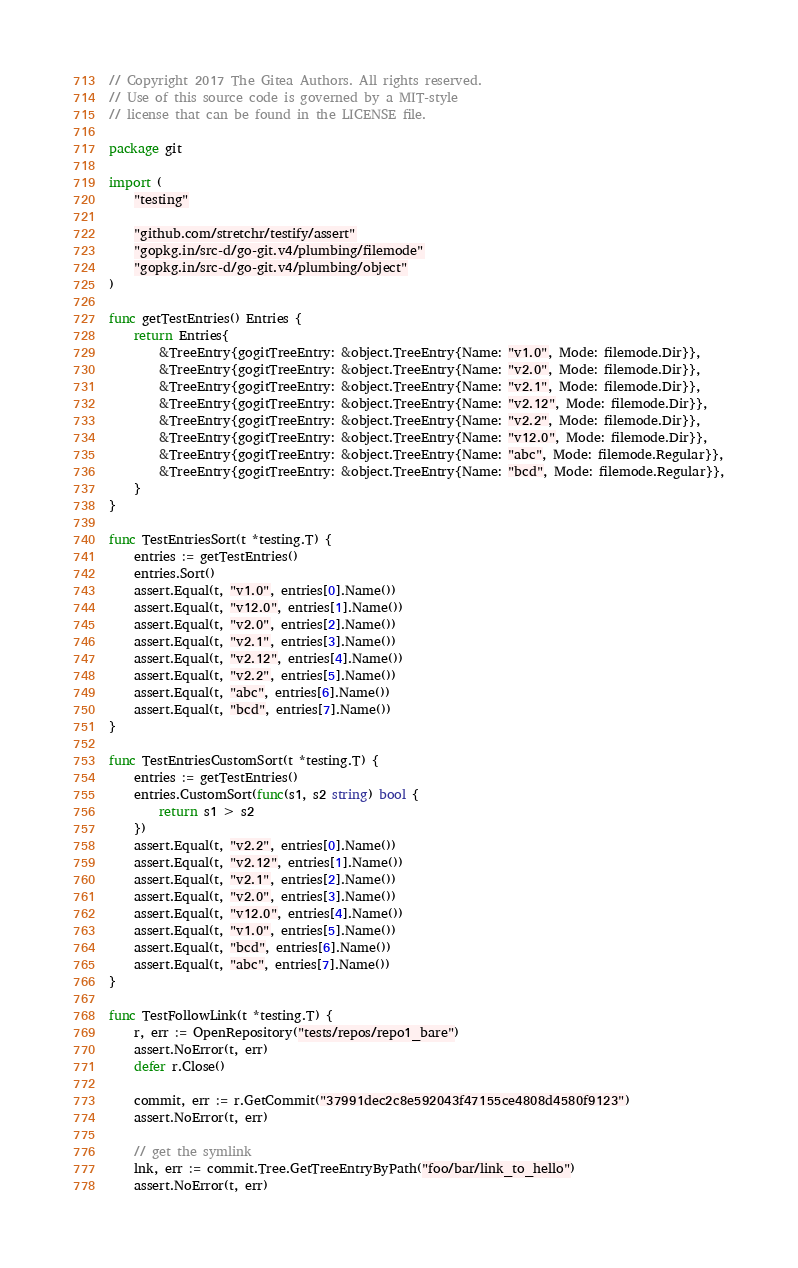<code> <loc_0><loc_0><loc_500><loc_500><_Go_>// Copyright 2017 The Gitea Authors. All rights reserved.
// Use of this source code is governed by a MIT-style
// license that can be found in the LICENSE file.

package git

import (
	"testing"

	"github.com/stretchr/testify/assert"
	"gopkg.in/src-d/go-git.v4/plumbing/filemode"
	"gopkg.in/src-d/go-git.v4/plumbing/object"
)

func getTestEntries() Entries {
	return Entries{
		&TreeEntry{gogitTreeEntry: &object.TreeEntry{Name: "v1.0", Mode: filemode.Dir}},
		&TreeEntry{gogitTreeEntry: &object.TreeEntry{Name: "v2.0", Mode: filemode.Dir}},
		&TreeEntry{gogitTreeEntry: &object.TreeEntry{Name: "v2.1", Mode: filemode.Dir}},
		&TreeEntry{gogitTreeEntry: &object.TreeEntry{Name: "v2.12", Mode: filemode.Dir}},
		&TreeEntry{gogitTreeEntry: &object.TreeEntry{Name: "v2.2", Mode: filemode.Dir}},
		&TreeEntry{gogitTreeEntry: &object.TreeEntry{Name: "v12.0", Mode: filemode.Dir}},
		&TreeEntry{gogitTreeEntry: &object.TreeEntry{Name: "abc", Mode: filemode.Regular}},
		&TreeEntry{gogitTreeEntry: &object.TreeEntry{Name: "bcd", Mode: filemode.Regular}},
	}
}

func TestEntriesSort(t *testing.T) {
	entries := getTestEntries()
	entries.Sort()
	assert.Equal(t, "v1.0", entries[0].Name())
	assert.Equal(t, "v12.0", entries[1].Name())
	assert.Equal(t, "v2.0", entries[2].Name())
	assert.Equal(t, "v2.1", entries[3].Name())
	assert.Equal(t, "v2.12", entries[4].Name())
	assert.Equal(t, "v2.2", entries[5].Name())
	assert.Equal(t, "abc", entries[6].Name())
	assert.Equal(t, "bcd", entries[7].Name())
}

func TestEntriesCustomSort(t *testing.T) {
	entries := getTestEntries()
	entries.CustomSort(func(s1, s2 string) bool {
		return s1 > s2
	})
	assert.Equal(t, "v2.2", entries[0].Name())
	assert.Equal(t, "v2.12", entries[1].Name())
	assert.Equal(t, "v2.1", entries[2].Name())
	assert.Equal(t, "v2.0", entries[3].Name())
	assert.Equal(t, "v12.0", entries[4].Name())
	assert.Equal(t, "v1.0", entries[5].Name())
	assert.Equal(t, "bcd", entries[6].Name())
	assert.Equal(t, "abc", entries[7].Name())
}

func TestFollowLink(t *testing.T) {
	r, err := OpenRepository("tests/repos/repo1_bare")
	assert.NoError(t, err)
	defer r.Close()

	commit, err := r.GetCommit("37991dec2c8e592043f47155ce4808d4580f9123")
	assert.NoError(t, err)

	// get the symlink
	lnk, err := commit.Tree.GetTreeEntryByPath("foo/bar/link_to_hello")
	assert.NoError(t, err)</code> 